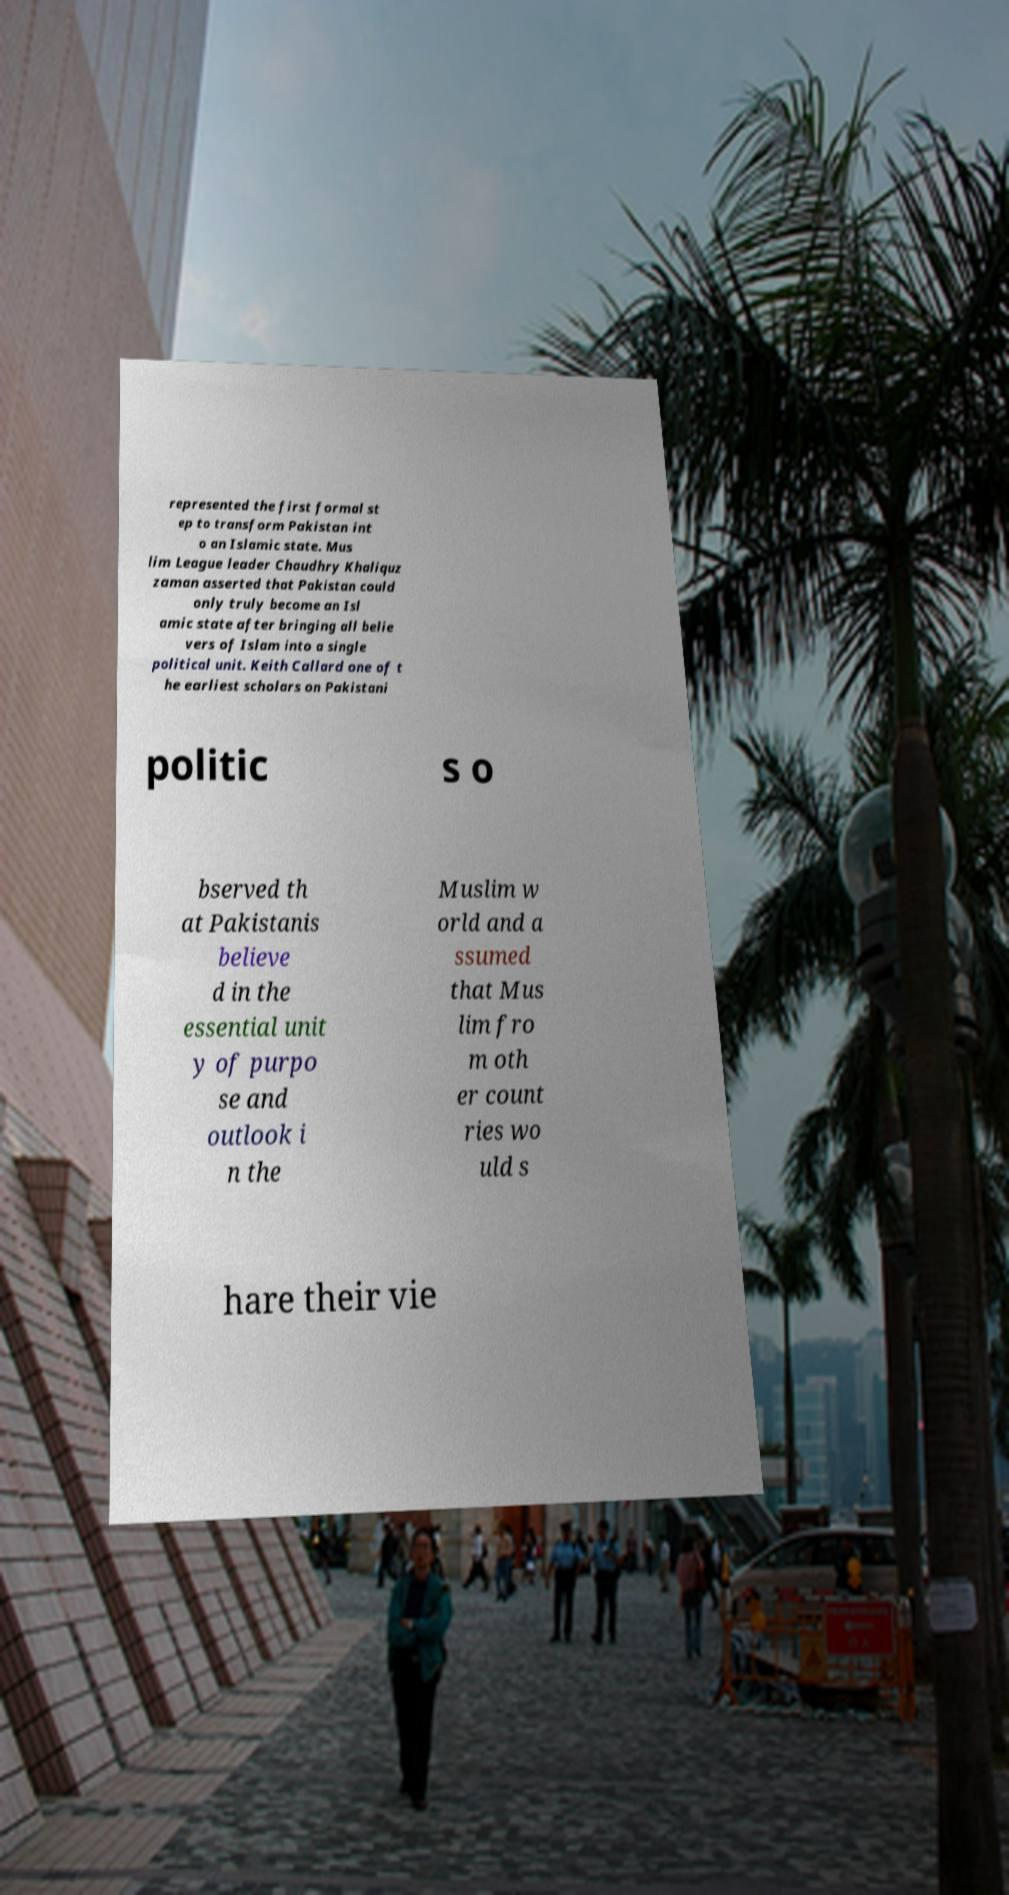Please read and relay the text visible in this image. What does it say? represented the first formal st ep to transform Pakistan int o an Islamic state. Mus lim League leader Chaudhry Khaliquz zaman asserted that Pakistan could only truly become an Isl amic state after bringing all belie vers of Islam into a single political unit. Keith Callard one of t he earliest scholars on Pakistani politic s o bserved th at Pakistanis believe d in the essential unit y of purpo se and outlook i n the Muslim w orld and a ssumed that Mus lim fro m oth er count ries wo uld s hare their vie 